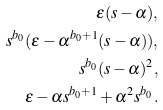<formula> <loc_0><loc_0><loc_500><loc_500>\epsilon ( s - \alpha ) , \\ s ^ { b _ { 0 } } ( \epsilon - \alpha ^ { b _ { 0 } + 1 } ( s - \alpha ) ) , \\ s ^ { b _ { 0 } } ( s - \alpha ) ^ { 2 } , \\ \epsilon - \alpha s ^ { b _ { 0 } + 1 } + \alpha ^ { 2 } s ^ { b _ { 0 } } .</formula> 